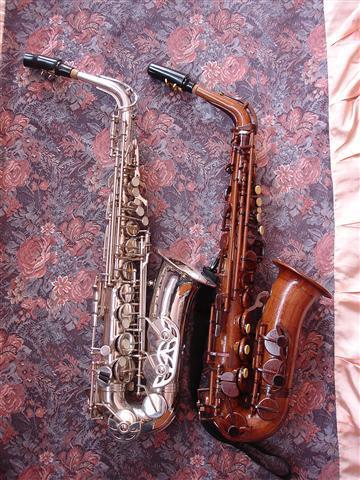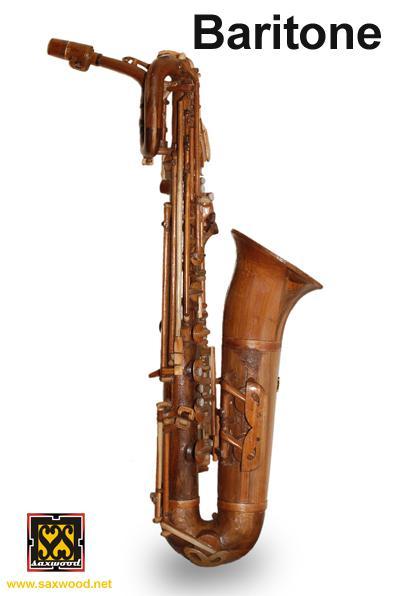The first image is the image on the left, the second image is the image on the right. For the images displayed, is the sentence "In one of the images there are two saxophones placed next to each other." factually correct? Answer yes or no. Yes. The first image is the image on the left, the second image is the image on the right. Considering the images on both sides, is "The right image features one wooden instrument on a white background." valid? Answer yes or no. Yes. The first image is the image on the left, the second image is the image on the right. Considering the images on both sides, is "The image on the right contains a single saxophone on a white background." valid? Answer yes or no. Yes. The first image is the image on the left, the second image is the image on the right. Given the left and right images, does the statement "At least one image has no background." hold true? Answer yes or no. Yes. 